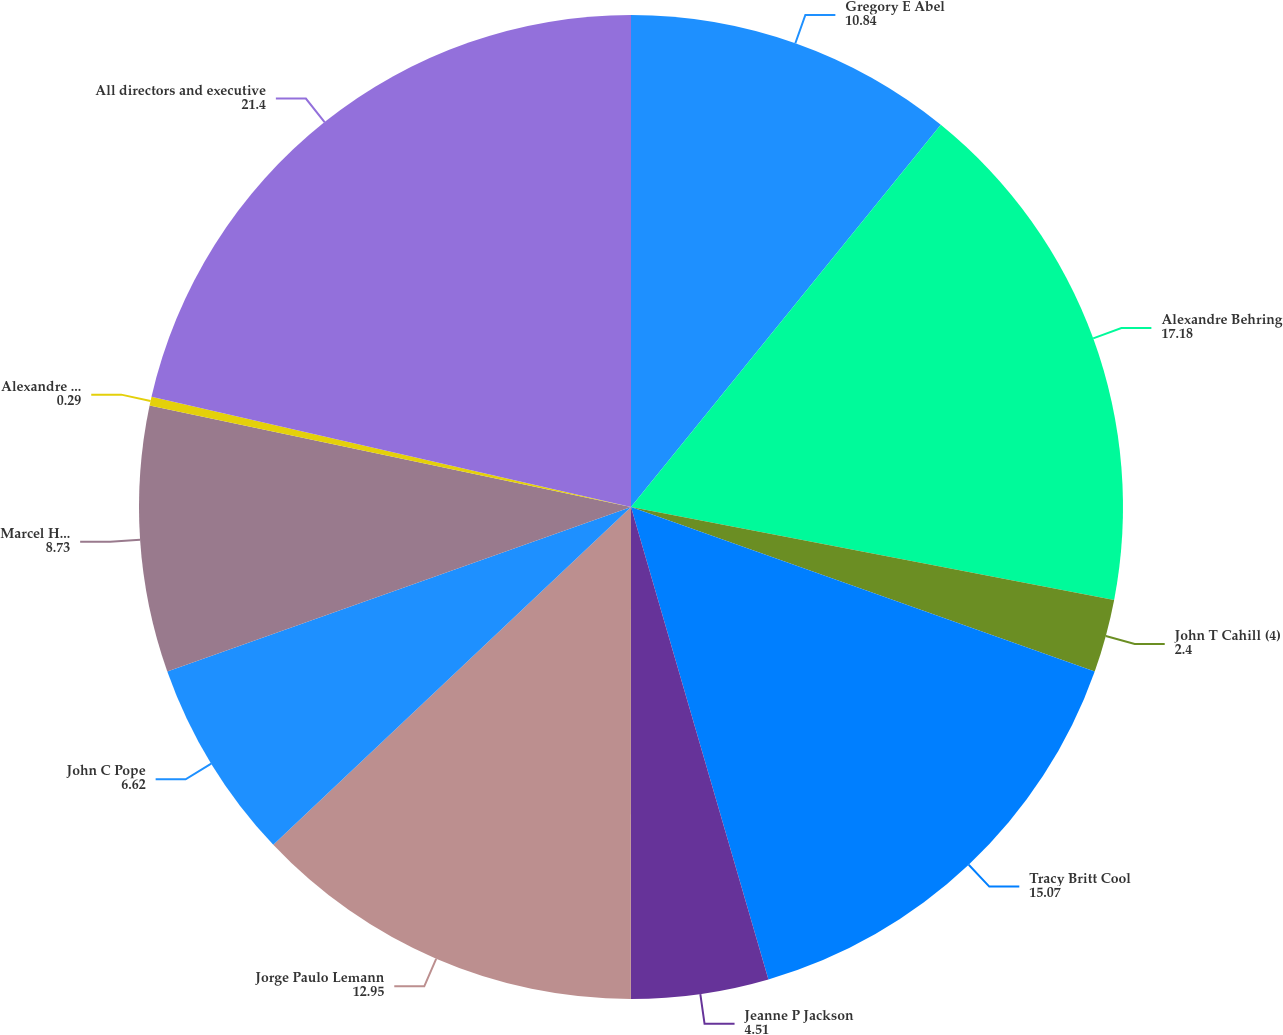<chart> <loc_0><loc_0><loc_500><loc_500><pie_chart><fcel>Gregory E Abel<fcel>Alexandre Behring<fcel>John T Cahill (4)<fcel>Tracy Britt Cool<fcel>Jeanne P Jackson<fcel>Jorge Paulo Lemann<fcel>John C Pope<fcel>Marcel Hermann Telles<fcel>Alexandre Van Damme<fcel>All directors and executive<nl><fcel>10.84%<fcel>17.18%<fcel>2.4%<fcel>15.07%<fcel>4.51%<fcel>12.95%<fcel>6.62%<fcel>8.73%<fcel>0.29%<fcel>21.4%<nl></chart> 